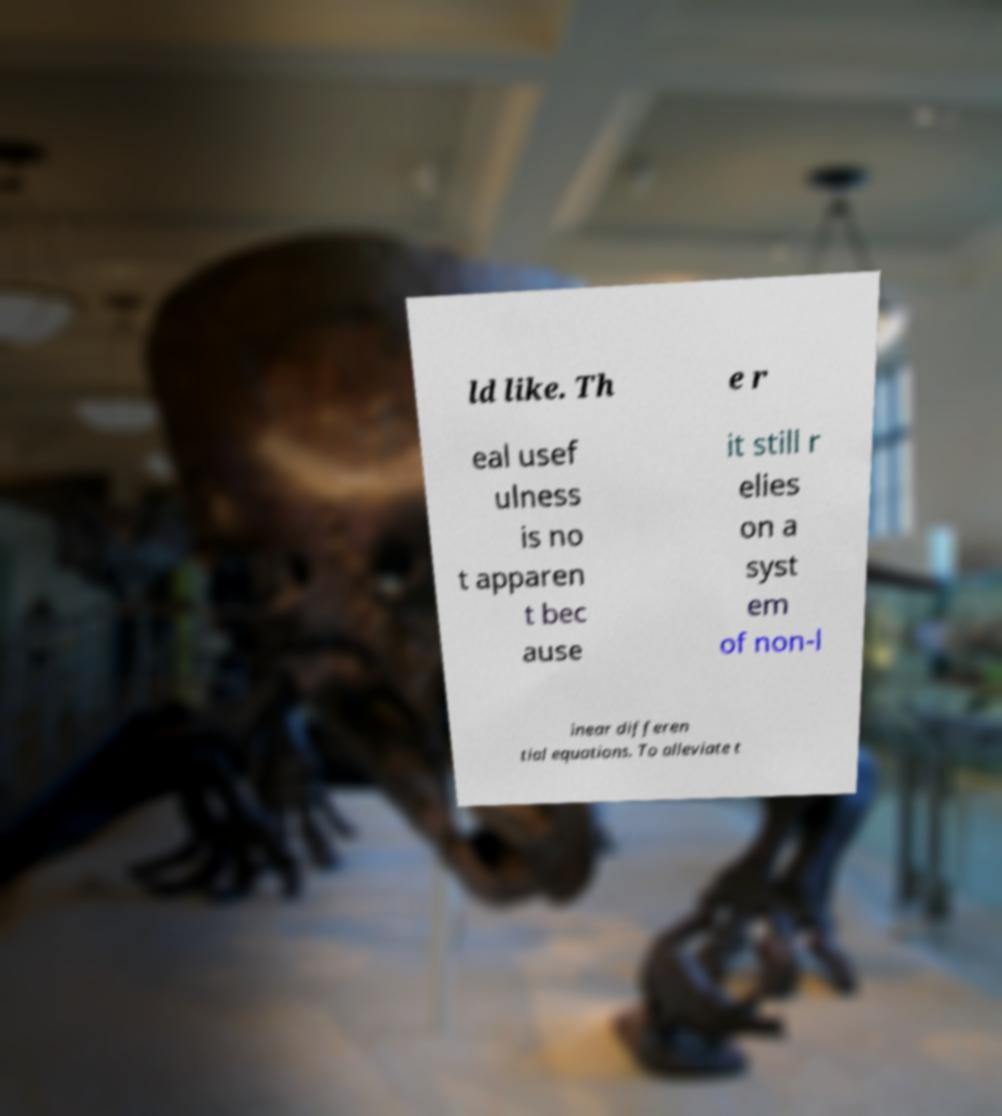Please read and relay the text visible in this image. What does it say? ld like. Th e r eal usef ulness is no t apparen t bec ause it still r elies on a syst em of non-l inear differen tial equations. To alleviate t 